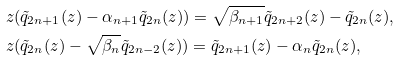<formula> <loc_0><loc_0><loc_500><loc_500>& z ( \tilde { q } _ { 2 n + 1 } ( z ) - \alpha _ { n + 1 } \tilde { q } _ { 2 n } ( z ) ) = \sqrt { \beta _ { n + 1 } } \tilde { q } _ { 2 n + 2 } ( z ) - \tilde { q } _ { 2 n } ( z ) , \\ & z ( \tilde { q } _ { 2 n } ( z ) - \sqrt { \beta _ { n } } \tilde { q } _ { 2 n - 2 } ( z ) ) = \tilde { q } _ { 2 n + 1 } ( z ) - \alpha _ { n } \tilde { q } _ { 2 n } ( z ) ,</formula> 